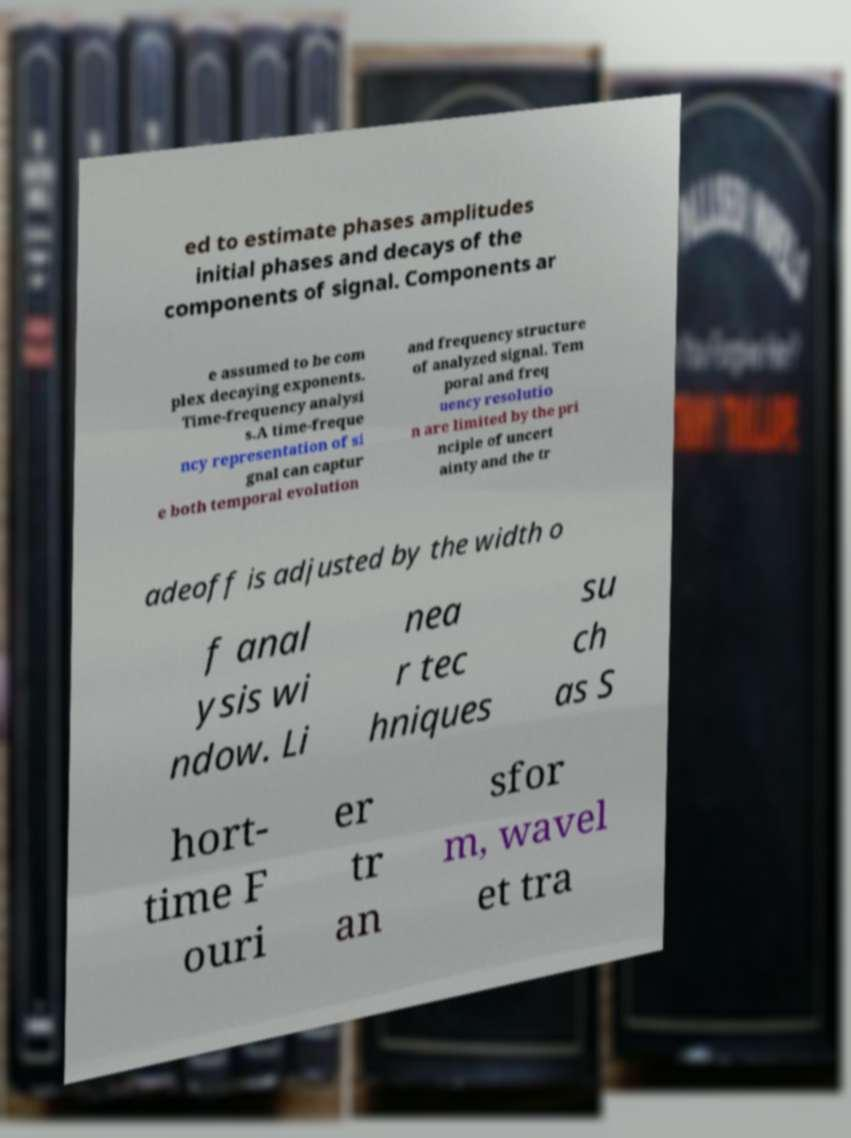Could you extract and type out the text from this image? ed to estimate phases amplitudes initial phases and decays of the components of signal. Components ar e assumed to be com plex decaying exponents. Time-frequency analysi s.A time-freque ncy representation of si gnal can captur e both temporal evolution and frequency structure of analyzed signal. Tem poral and freq uency resolutio n are limited by the pri nciple of uncert ainty and the tr adeoff is adjusted by the width o f anal ysis wi ndow. Li nea r tec hniques su ch as S hort- time F ouri er tr an sfor m, wavel et tra 